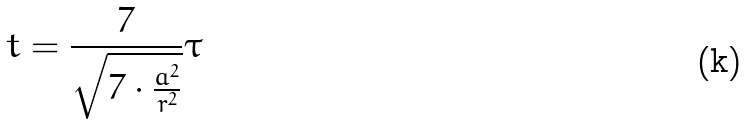Convert formula to latex. <formula><loc_0><loc_0><loc_500><loc_500>t = \frac { 7 } { \sqrt { 7 \cdot \frac { a ^ { 2 } } { r ^ { 2 } } } } \tau</formula> 